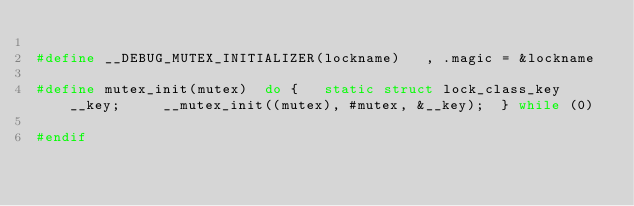<code> <loc_0><loc_0><loc_500><loc_500><_C_>
#define __DEBUG_MUTEX_INITIALIZER(lockname)   , .magic = &lockname

#define mutex_init(mutex)  do {   static struct lock_class_key __key;     __mutex_init((mutex), #mutex, &__key);  } while (0)

#endif
</code> 